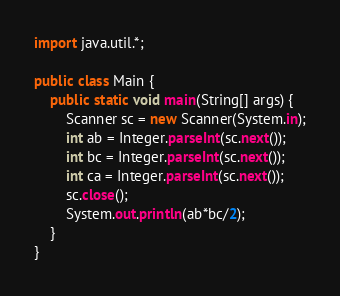Convert code to text. <code><loc_0><loc_0><loc_500><loc_500><_Java_>import java.util.*;

public class Main {
	public static void main(String[] args) {
		Scanner sc = new Scanner(System.in);
		int ab = Integer.parseInt(sc.next());
		int bc = Integer.parseInt(sc.next());
		int ca = Integer.parseInt(sc.next());
		sc.close();
		System.out.println(ab*bc/2);
	}
}
</code> 